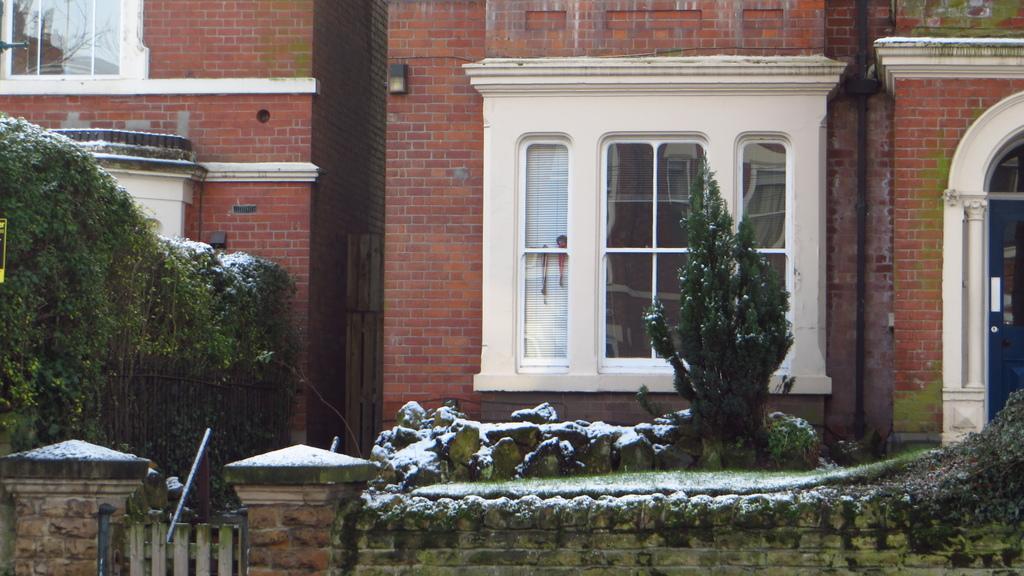In one or two sentences, can you explain what this image depicts? In this image we can see buildings, windows, pipelines, creepers, pillars, trees, rocks and snow. 